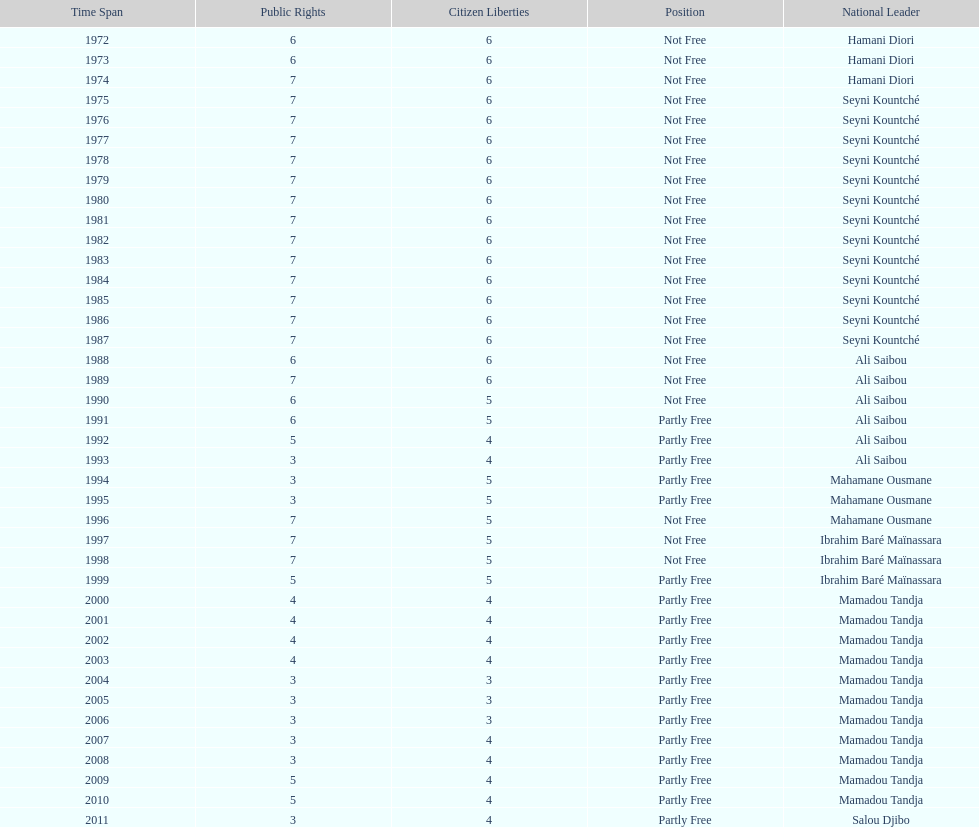How long did it take for civil liberties to decrease below 6? 18 years. 